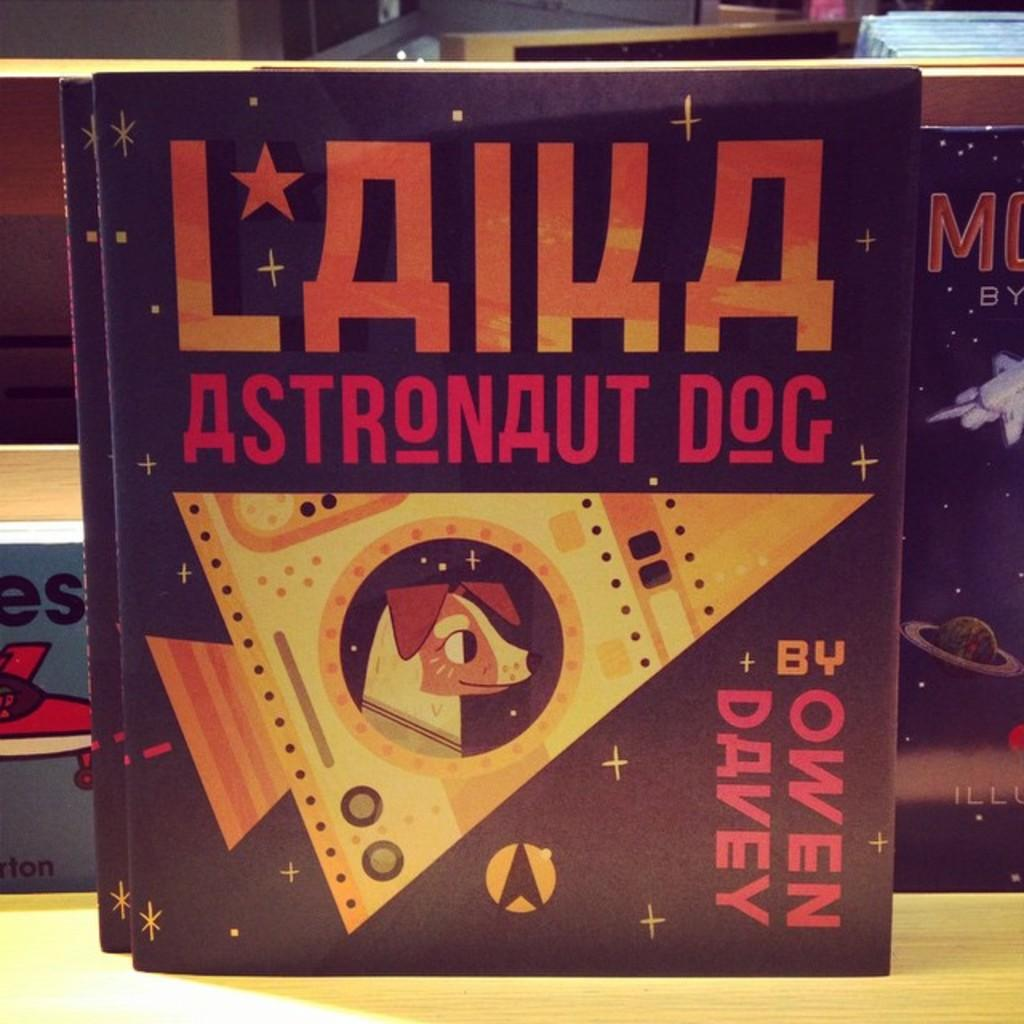<image>
Summarize the visual content of the image. A book cover lists the author as Owen Davey. 